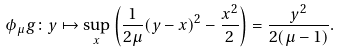Convert formula to latex. <formula><loc_0><loc_0><loc_500><loc_500>\phi _ { \mu } g \colon y \mapsto \sup _ { x } \left ( \frac { 1 } { 2 \mu } ( y - x ) ^ { 2 } - \frac { x ^ { 2 } } { 2 } \right ) = \frac { y ^ { 2 } } { 2 ( \mu - 1 ) } .</formula> 